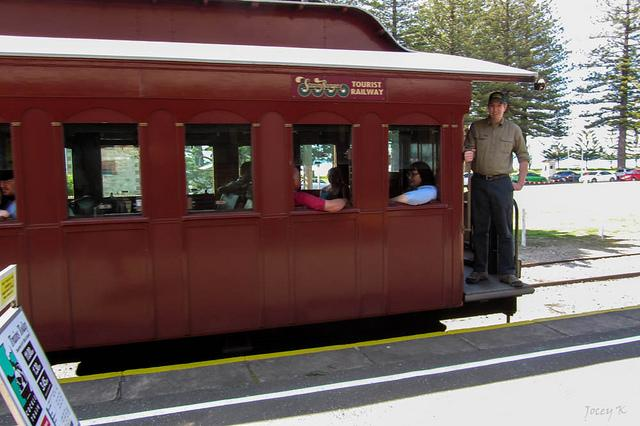What type passengers board this train? tourists 